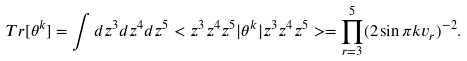Convert formula to latex. <formula><loc_0><loc_0><loc_500><loc_500>T r [ \theta ^ { k } ] = \int d z ^ { 3 } d z ^ { 4 } d z ^ { 5 } < z ^ { 3 } z ^ { 4 } z ^ { 5 } | \theta ^ { k } | z ^ { 3 } z ^ { 4 } z ^ { 5 } > = \prod _ { r = 3 } ^ { 5 } ( 2 \sin \pi k v _ { r } ) ^ { - 2 } .</formula> 